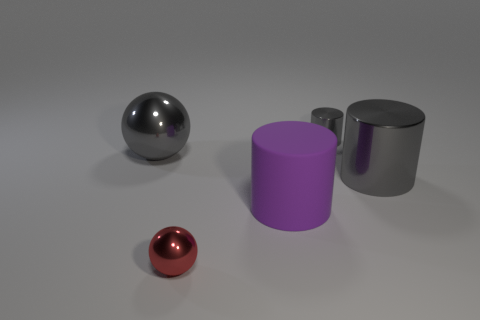How many objects are big red metal blocks or tiny gray metallic things?
Provide a succinct answer. 1. There is a gray shiny cylinder behind the gray shiny ball; how big is it?
Provide a succinct answer. Small. What number of other things are there of the same material as the large gray sphere
Offer a terse response. 3. Is there a gray metallic ball that is in front of the tiny red thing in front of the big matte object?
Give a very brief answer. No. Are there any other things that are the same shape as the purple thing?
Keep it short and to the point. Yes. The other big metal object that is the same shape as the red metallic thing is what color?
Offer a very short reply. Gray. What size is the rubber cylinder?
Your answer should be very brief. Large. Is the number of matte cylinders that are to the left of the tiny red shiny thing less than the number of matte balls?
Ensure brevity in your answer.  No. Are the small gray thing and the sphere behind the large shiny cylinder made of the same material?
Offer a very short reply. Yes. There is a purple matte object that is in front of the tiny gray shiny thing behind the big purple cylinder; are there any big gray objects that are on the right side of it?
Your answer should be compact. Yes. 